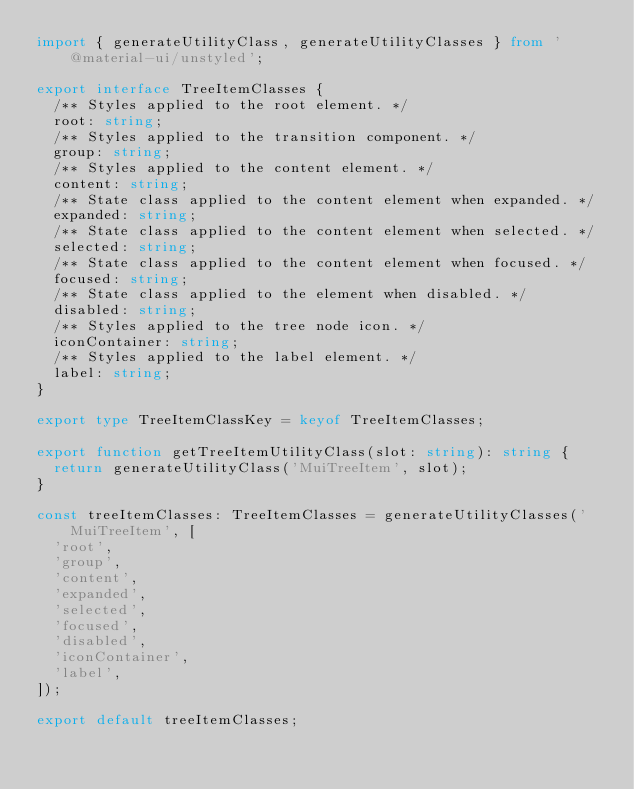<code> <loc_0><loc_0><loc_500><loc_500><_TypeScript_>import { generateUtilityClass, generateUtilityClasses } from '@material-ui/unstyled';

export interface TreeItemClasses {
  /** Styles applied to the root element. */
  root: string;
  /** Styles applied to the transition component. */
  group: string;
  /** Styles applied to the content element. */
  content: string;
  /** State class applied to the content element when expanded. */
  expanded: string;
  /** State class applied to the content element when selected. */
  selected: string;
  /** State class applied to the content element when focused. */
  focused: string;
  /** State class applied to the element when disabled. */
  disabled: string;
  /** Styles applied to the tree node icon. */
  iconContainer: string;
  /** Styles applied to the label element. */
  label: string;
}

export type TreeItemClassKey = keyof TreeItemClasses;

export function getTreeItemUtilityClass(slot: string): string {
  return generateUtilityClass('MuiTreeItem', slot);
}

const treeItemClasses: TreeItemClasses = generateUtilityClasses('MuiTreeItem', [
  'root',
  'group',
  'content',
  'expanded',
  'selected',
  'focused',
  'disabled',
  'iconContainer',
  'label',
]);

export default treeItemClasses;
</code> 